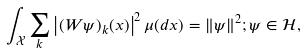<formula> <loc_0><loc_0><loc_500><loc_500>\int _ { \mathcal { X } } \sum _ { k } \left | ( W \psi ) _ { k } ( x ) \right | ^ { 2 } \mu ( d x ) = \| \psi \| ^ { 2 } ; \psi \in \mathcal { H } ,</formula> 